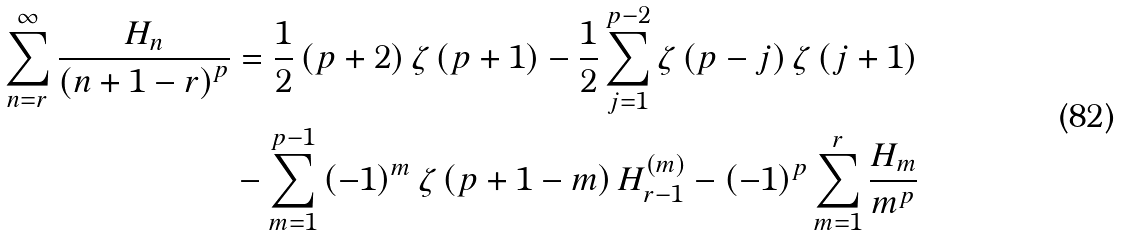Convert formula to latex. <formula><loc_0><loc_0><loc_500><loc_500>\sum _ { n = r } ^ { \infty } \frac { H _ { n } } { \left ( n + 1 - r \right ) ^ { p } } & = \frac { 1 } { 2 } \left ( p + 2 \right ) \zeta \left ( p + 1 \right ) - \frac { 1 } { 2 } \sum _ { j = 1 } ^ { p - 2 } \zeta \left ( p - j \right ) \zeta \left ( j + 1 \right ) \\ & - \sum _ { m = 1 } ^ { p - 1 } \left ( - 1 \right ) ^ { m } \zeta \left ( p + 1 - m \right ) H _ { r - 1 } ^ { \left ( m \right ) } - \left ( - 1 \right ) ^ { p } \sum _ { m = 1 } ^ { r } \frac { H _ { m } } { m ^ { p } }</formula> 